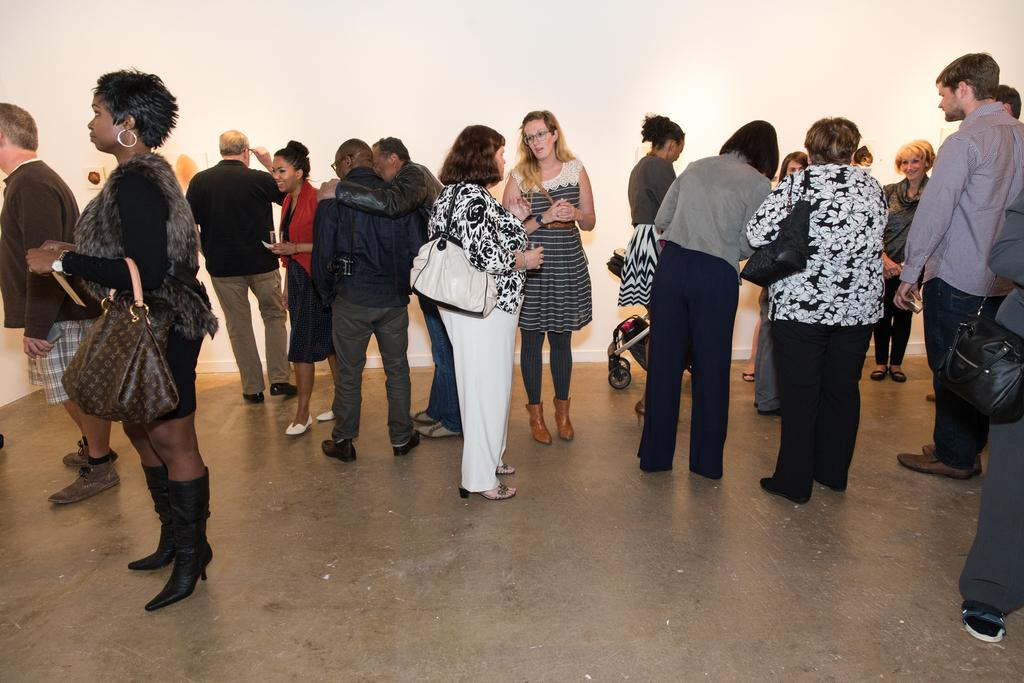What are the people in the image doing? The persons in the image are standing on the floor. Can you describe any specific actions or items being carried by the people? One person is carrying a bag. What can be seen in the background of the image? There is a wall in the background of the image. What is visible beneath the people's feet? The floor is visible in the image. What type of donkey can be seen walking on the wall in the image? There is no donkey present in the image, and the wall is not depicted as having any animals walking on it. 